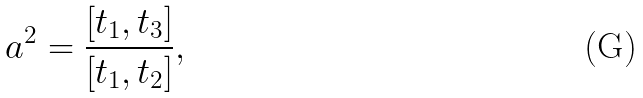Convert formula to latex. <formula><loc_0><loc_0><loc_500><loc_500>a ^ { 2 } = \frac { [ t _ { 1 } , t _ { 3 } ] } { [ t _ { 1 } , t _ { 2 } ] } ,</formula> 